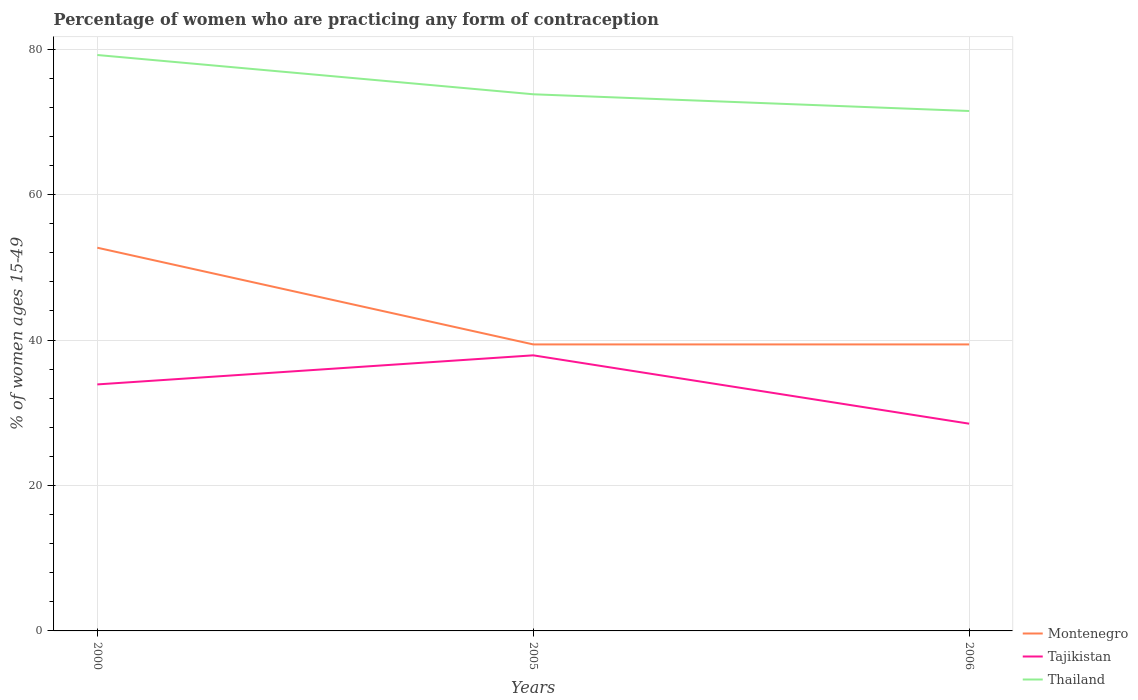Is the number of lines equal to the number of legend labels?
Offer a terse response. Yes. Across all years, what is the maximum percentage of women who are practicing any form of contraception in Tajikistan?
Your answer should be very brief. 28.5. In which year was the percentage of women who are practicing any form of contraception in Thailand maximum?
Your answer should be compact. 2006. What is the total percentage of women who are practicing any form of contraception in Tajikistan in the graph?
Your response must be concise. 5.4. What is the difference between the highest and the second highest percentage of women who are practicing any form of contraception in Tajikistan?
Your answer should be very brief. 9.4. What is the difference between the highest and the lowest percentage of women who are practicing any form of contraception in Montenegro?
Ensure brevity in your answer.  1. Is the percentage of women who are practicing any form of contraception in Tajikistan strictly greater than the percentage of women who are practicing any form of contraception in Thailand over the years?
Provide a succinct answer. Yes. How many years are there in the graph?
Your answer should be very brief. 3. What is the difference between two consecutive major ticks on the Y-axis?
Offer a terse response. 20. Does the graph contain any zero values?
Your response must be concise. No. Does the graph contain grids?
Your response must be concise. Yes. Where does the legend appear in the graph?
Ensure brevity in your answer.  Bottom right. How many legend labels are there?
Offer a very short reply. 3. How are the legend labels stacked?
Offer a terse response. Vertical. What is the title of the graph?
Keep it short and to the point. Percentage of women who are practicing any form of contraception. What is the label or title of the X-axis?
Ensure brevity in your answer.  Years. What is the label or title of the Y-axis?
Offer a terse response. % of women ages 15-49. What is the % of women ages 15-49 in Montenegro in 2000?
Give a very brief answer. 52.7. What is the % of women ages 15-49 in Tajikistan in 2000?
Offer a very short reply. 33.9. What is the % of women ages 15-49 in Thailand in 2000?
Give a very brief answer. 79.2. What is the % of women ages 15-49 of Montenegro in 2005?
Your answer should be compact. 39.4. What is the % of women ages 15-49 in Tajikistan in 2005?
Make the answer very short. 37.9. What is the % of women ages 15-49 in Thailand in 2005?
Offer a very short reply. 73.8. What is the % of women ages 15-49 of Montenegro in 2006?
Offer a terse response. 39.4. What is the % of women ages 15-49 in Thailand in 2006?
Your answer should be compact. 71.5. Across all years, what is the maximum % of women ages 15-49 of Montenegro?
Your response must be concise. 52.7. Across all years, what is the maximum % of women ages 15-49 in Tajikistan?
Your answer should be very brief. 37.9. Across all years, what is the maximum % of women ages 15-49 of Thailand?
Offer a very short reply. 79.2. Across all years, what is the minimum % of women ages 15-49 in Montenegro?
Keep it short and to the point. 39.4. Across all years, what is the minimum % of women ages 15-49 of Thailand?
Ensure brevity in your answer.  71.5. What is the total % of women ages 15-49 in Montenegro in the graph?
Provide a succinct answer. 131.5. What is the total % of women ages 15-49 of Tajikistan in the graph?
Ensure brevity in your answer.  100.3. What is the total % of women ages 15-49 in Thailand in the graph?
Make the answer very short. 224.5. What is the difference between the % of women ages 15-49 of Montenegro in 2000 and that in 2005?
Your answer should be very brief. 13.3. What is the difference between the % of women ages 15-49 of Thailand in 2000 and that in 2005?
Ensure brevity in your answer.  5.4. What is the difference between the % of women ages 15-49 of Tajikistan in 2000 and that in 2006?
Your answer should be compact. 5.4. What is the difference between the % of women ages 15-49 in Montenegro in 2005 and that in 2006?
Provide a short and direct response. 0. What is the difference between the % of women ages 15-49 in Thailand in 2005 and that in 2006?
Provide a succinct answer. 2.3. What is the difference between the % of women ages 15-49 in Montenegro in 2000 and the % of women ages 15-49 in Tajikistan in 2005?
Your answer should be very brief. 14.8. What is the difference between the % of women ages 15-49 in Montenegro in 2000 and the % of women ages 15-49 in Thailand in 2005?
Ensure brevity in your answer.  -21.1. What is the difference between the % of women ages 15-49 of Tajikistan in 2000 and the % of women ages 15-49 of Thailand in 2005?
Your answer should be very brief. -39.9. What is the difference between the % of women ages 15-49 of Montenegro in 2000 and the % of women ages 15-49 of Tajikistan in 2006?
Provide a succinct answer. 24.2. What is the difference between the % of women ages 15-49 of Montenegro in 2000 and the % of women ages 15-49 of Thailand in 2006?
Provide a succinct answer. -18.8. What is the difference between the % of women ages 15-49 in Tajikistan in 2000 and the % of women ages 15-49 in Thailand in 2006?
Offer a terse response. -37.6. What is the difference between the % of women ages 15-49 of Montenegro in 2005 and the % of women ages 15-49 of Thailand in 2006?
Your response must be concise. -32.1. What is the difference between the % of women ages 15-49 of Tajikistan in 2005 and the % of women ages 15-49 of Thailand in 2006?
Your answer should be very brief. -33.6. What is the average % of women ages 15-49 of Montenegro per year?
Your response must be concise. 43.83. What is the average % of women ages 15-49 of Tajikistan per year?
Give a very brief answer. 33.43. What is the average % of women ages 15-49 of Thailand per year?
Provide a succinct answer. 74.83. In the year 2000, what is the difference between the % of women ages 15-49 in Montenegro and % of women ages 15-49 in Thailand?
Offer a terse response. -26.5. In the year 2000, what is the difference between the % of women ages 15-49 in Tajikistan and % of women ages 15-49 in Thailand?
Your answer should be very brief. -45.3. In the year 2005, what is the difference between the % of women ages 15-49 of Montenegro and % of women ages 15-49 of Thailand?
Keep it short and to the point. -34.4. In the year 2005, what is the difference between the % of women ages 15-49 of Tajikistan and % of women ages 15-49 of Thailand?
Your response must be concise. -35.9. In the year 2006, what is the difference between the % of women ages 15-49 of Montenegro and % of women ages 15-49 of Tajikistan?
Offer a terse response. 10.9. In the year 2006, what is the difference between the % of women ages 15-49 in Montenegro and % of women ages 15-49 in Thailand?
Ensure brevity in your answer.  -32.1. In the year 2006, what is the difference between the % of women ages 15-49 in Tajikistan and % of women ages 15-49 in Thailand?
Your response must be concise. -43. What is the ratio of the % of women ages 15-49 in Montenegro in 2000 to that in 2005?
Provide a short and direct response. 1.34. What is the ratio of the % of women ages 15-49 of Tajikistan in 2000 to that in 2005?
Your answer should be very brief. 0.89. What is the ratio of the % of women ages 15-49 of Thailand in 2000 to that in 2005?
Your response must be concise. 1.07. What is the ratio of the % of women ages 15-49 in Montenegro in 2000 to that in 2006?
Your response must be concise. 1.34. What is the ratio of the % of women ages 15-49 of Tajikistan in 2000 to that in 2006?
Your answer should be very brief. 1.19. What is the ratio of the % of women ages 15-49 in Thailand in 2000 to that in 2006?
Provide a short and direct response. 1.11. What is the ratio of the % of women ages 15-49 in Tajikistan in 2005 to that in 2006?
Your answer should be very brief. 1.33. What is the ratio of the % of women ages 15-49 in Thailand in 2005 to that in 2006?
Keep it short and to the point. 1.03. What is the difference between the highest and the second highest % of women ages 15-49 in Montenegro?
Provide a succinct answer. 13.3. What is the difference between the highest and the second highest % of women ages 15-49 of Tajikistan?
Your response must be concise. 4. 